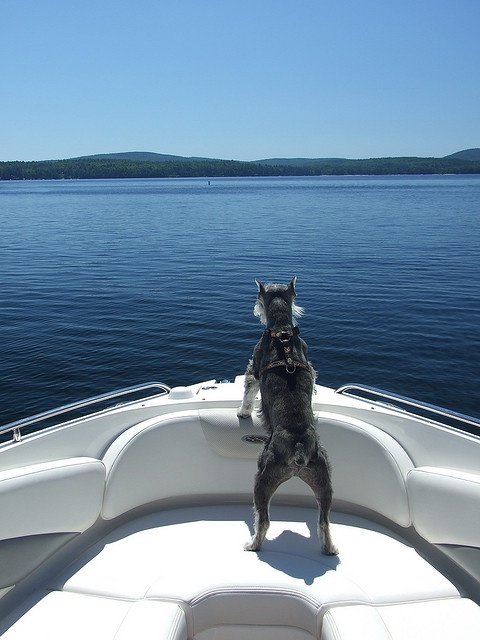Describe the objects in this image and their specific colors. I can see boat in lightblue, white, darkgray, and gray tones and dog in lightblue, black, gray, and darkgray tones in this image. 